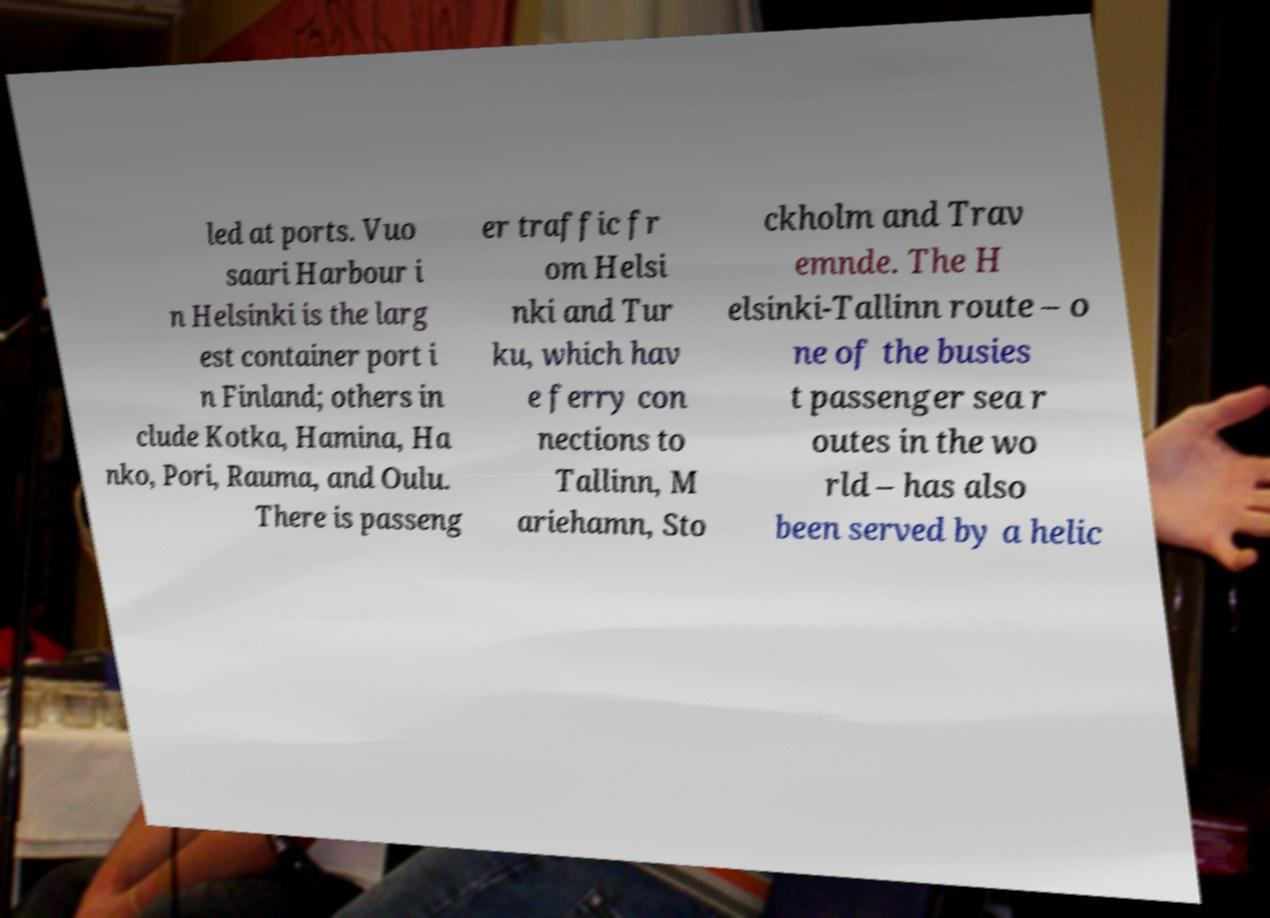Could you assist in decoding the text presented in this image and type it out clearly? led at ports. Vuo saari Harbour i n Helsinki is the larg est container port i n Finland; others in clude Kotka, Hamina, Ha nko, Pori, Rauma, and Oulu. There is passeng er traffic fr om Helsi nki and Tur ku, which hav e ferry con nections to Tallinn, M ariehamn, Sto ckholm and Trav emnde. The H elsinki-Tallinn route – o ne of the busies t passenger sea r outes in the wo rld – has also been served by a helic 